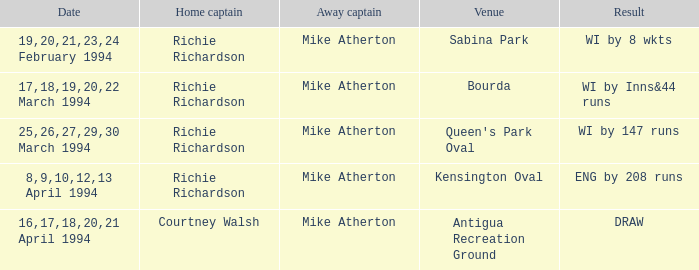What is the result of Courtney Walsh ? DRAW. 